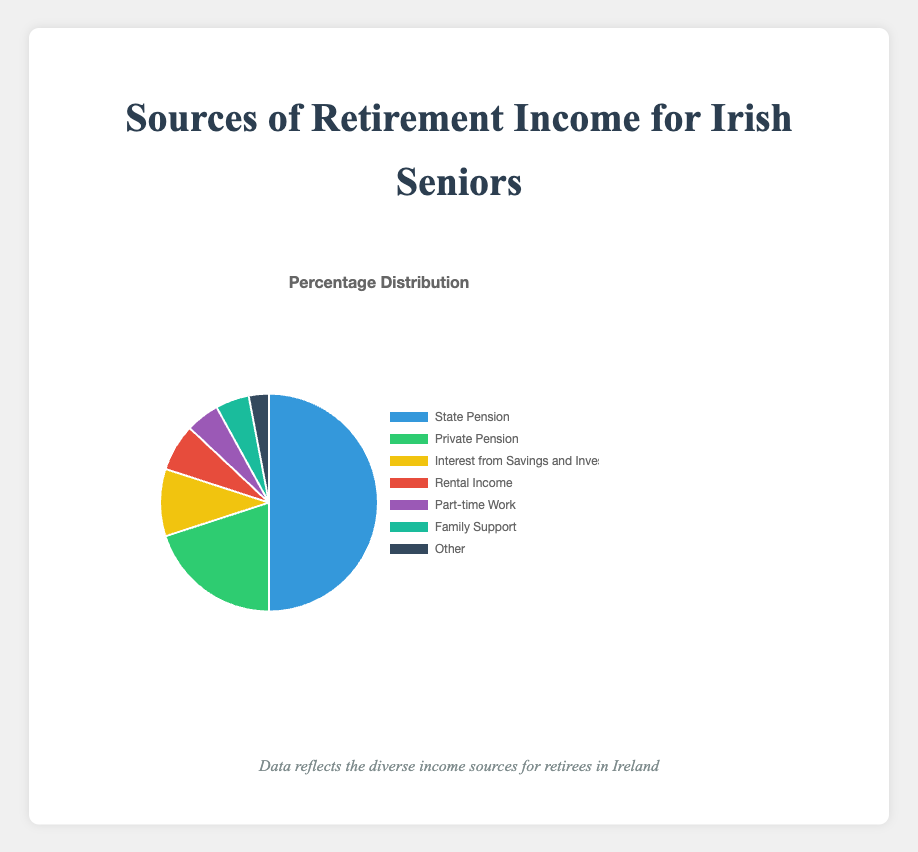Which source accounts for the highest percentage of retirement income? The pie chart labels indicate that "State Pension" has the largest slice. Its percentage is labeled as 50%.
Answer: State Pension What is the combined percentage of "Private Pension" and "Interest from Savings and Investments"? To find the combined percentage, we sum up the percentages of "Private Pension" (20%) and "Interest from Savings and Investments" (10%).
Answer: 30% Which source contributes less to retirement income: "Rental Income" or "Part-time Work"? Referring to the pie chart, "Part-time Work" is 5% and "Rental Income" is 7%. Since 5% is less than 7%, the source "Part-time Work" contributes less.
Answer: Part-time Work What's the difference in percentage between "Family Support" and "Other"? "Family Support" is 5%, and "Other" is 3%. The difference is calculated by subtracting the percentages: 5% - 3%.
Answer: 2% Arrange the sources in descending order of their percentage contribution. The sources' percentages are State Pension (50%), Private Pension (20%), Interest from Savings and Investments (10%), Rental Income (7%), Part-time Work (5%), Family Support (5%), and Other (3%). Arranging them from highest to lowest: State Pension, Private Pension, Interest from Savings and Investments, Rental Income, Part-time Work, Family Support, Other.
Answer: State Pension, Private Pension, Interest from Savings and Investments, Rental Income, Part-time Work, Family Support, Other Which colored segment represents "Interest from Savings and Investments"? From the chart's legend and the colors assigned to each segment, "Interest from Savings and Investments" is represented by the yellow segment.
Answer: Yellow Is the percentage of income from "Family Support" greater than or equal to any other sources? Yes, "Family Support" is 5%, which is equal to "Part-time Work" (5%) and greater than "Other" (3%).
Answer: Yes What is the total percentage of sources other than "State Pension" and "Private Pension"? To find the total, sum the percentages of all sources excluding "State Pension" (50%) and "Private Pension" (20%): 10% (Interest) + 7% (Rental) + 5% (Part-time) + 5% (Family) + 3% (Other) = 30%.
Answer: 30% If the percentage for "State Pension" were to decrease by 10%, how much would that percentage be? The current percentage for "State Pension" is 50%. Decreasing this by 10% gives 50% - 10% = 40%.
Answer: 40% Which sources together contribute more than the "State Pension" alone? Adding up the percentages for sources other than "State Pension": 20% (Private Pension) + 10% (Interest) + 7% (Rental) + 5% (Part-time) + 5% (Family) + 3% (Other) = 50%. Together, these sources sum to 50%, which equals rather than exceeds "State Pension". Thus, no sources together exceed "State Pension" alone.
Answer: None 